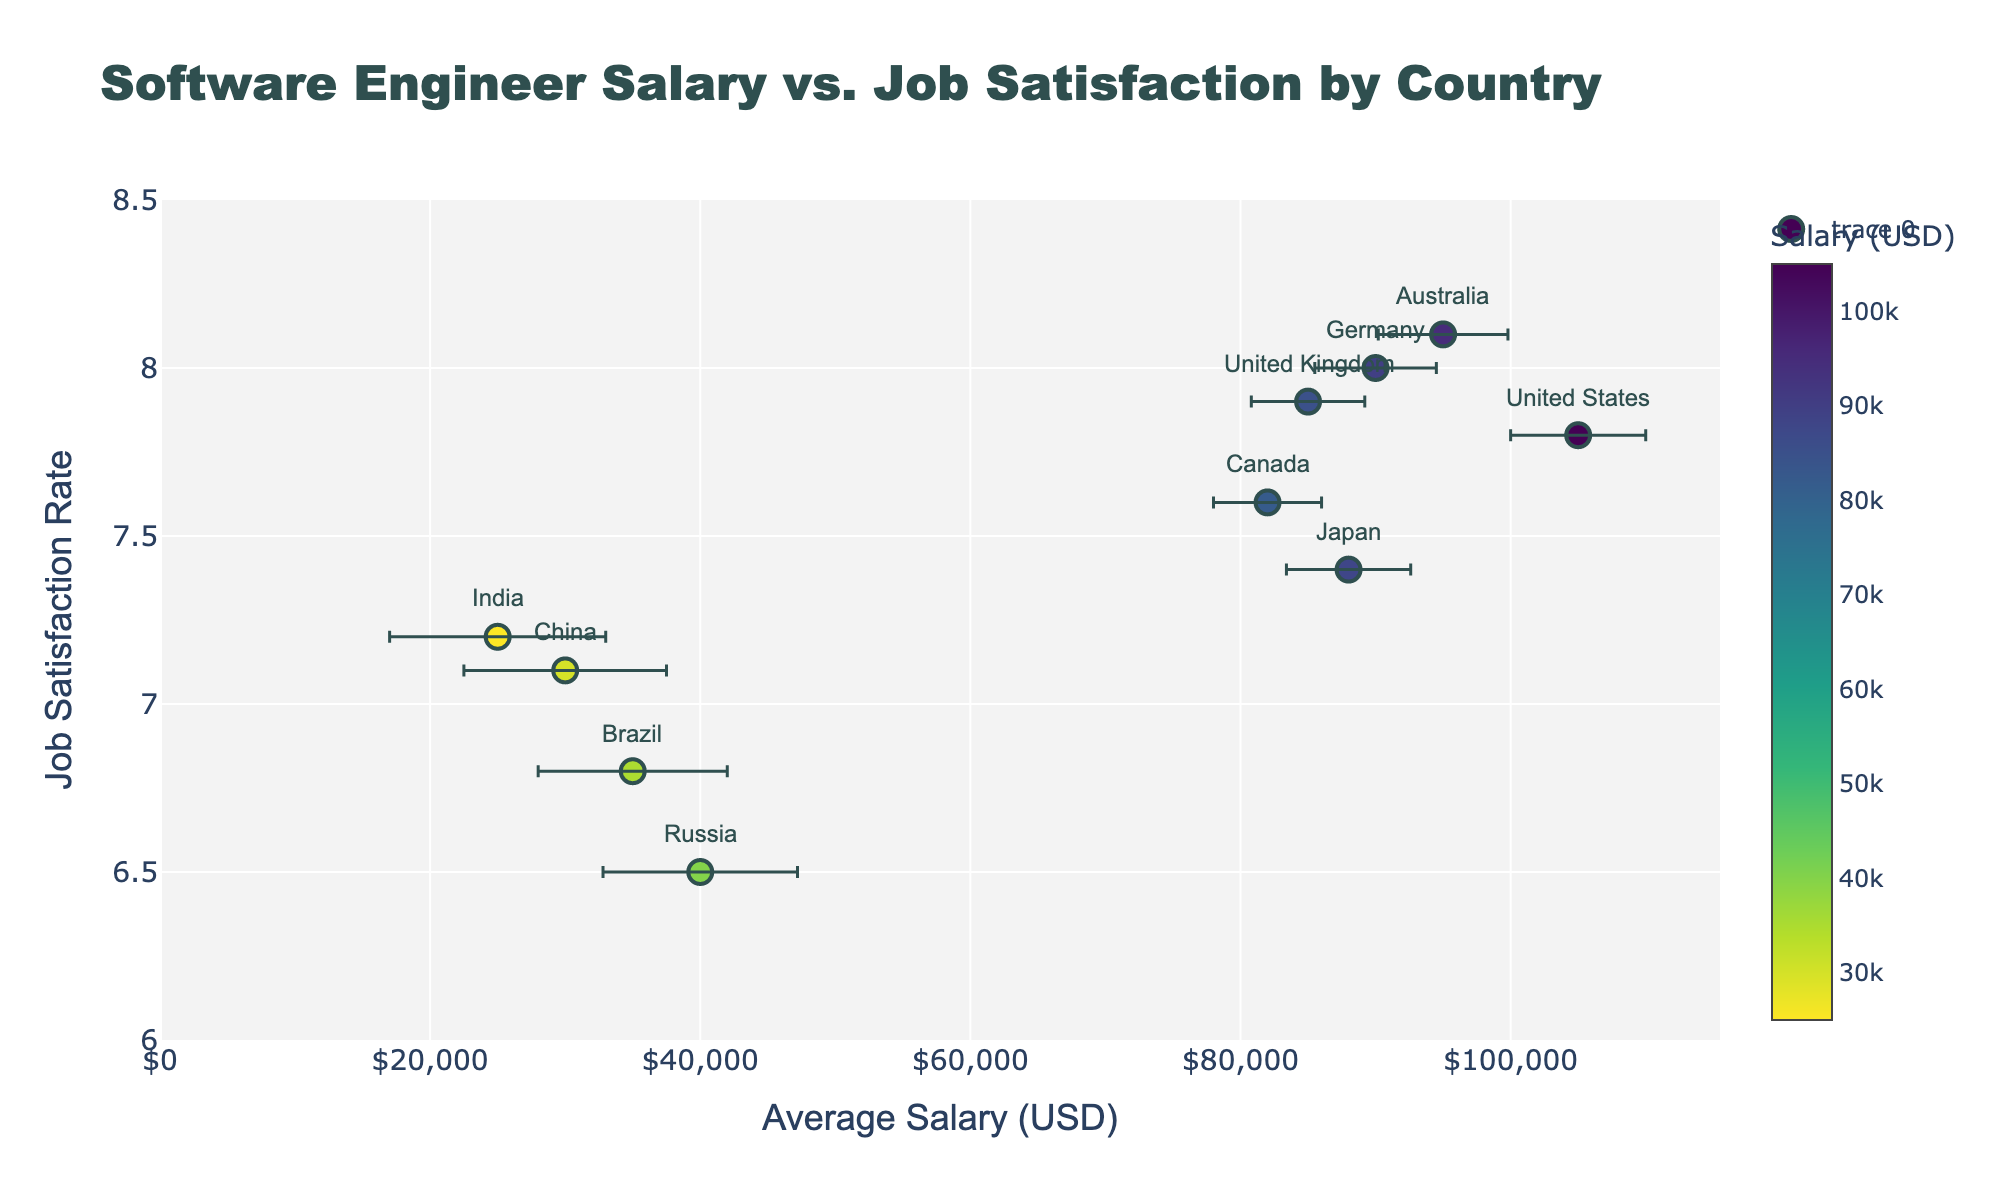What is the title of the plot? The title is displayed at the top center of the plot in a large, bold font. It helps understand the main theme of the plot.
Answer: Software Engineer Salary vs. Job Satisfaction by Country How many countries are represented in the plot? There are distinct markers for each country. By counting these markers, we can determine the number of countries represented.
Answer: 10 Which country has the highest average salary for software engineers? Look for the highest value on the x-axis (Average Salary). The country with the marker at this position represents the highest average salary.
Answer: United States What is the range of job satisfaction rates shown in the plot? Examine the y-axis to see the lowest and highest values marked. This will provide the range of job satisfaction rates.
Answer: 6.5 to 8.1 Which country has the lowest job satisfaction rate? Find the marker closest to the bottom of the y-axis. The label alongside this marker will indicate the country with the lowest satisfaction rate.
Answer: Russia How does the average salary in Japan compare to Canada? Identify the markers for Japan and Canada. Compare their positions on the x-axis to see which has a higher or lower average salary.
Answer: Japan has a lower average salary than Canada Which country shows the largest economic factor error? The length of the error bars indicates the economic factor error. The country with the longest error bar represents the largest error.
Answer: India What is the average job satisfaction rate among countries shown? Obtain the job satisfaction rate values for all countries, sum them up, and then divide by the number of countries to find the average.
Answer: (7.8 + 7.6 + 8.0 + 7.2 + 7.9 + 8.1 + 7.4 + 6.8 + 6.5 + 7.1) / 10 = 7.24 Which two countries have job satisfaction rates closest to each other? Compare the job satisfaction rates of all pairs of countries. Countries with the smallest difference between their satisfaction rates are the closest.
Answer: Canada and United Kingdom Do higher salaries correlate with higher job satisfaction rates in the plot? Observe the general trend of markers. If markers for higher salaries tend toward higher satisfaction rates, there is a positive correlation. This needs examining the overall dispersion and trend direction in the plot.
Answer: Not necessarily; no clear consistent trend 